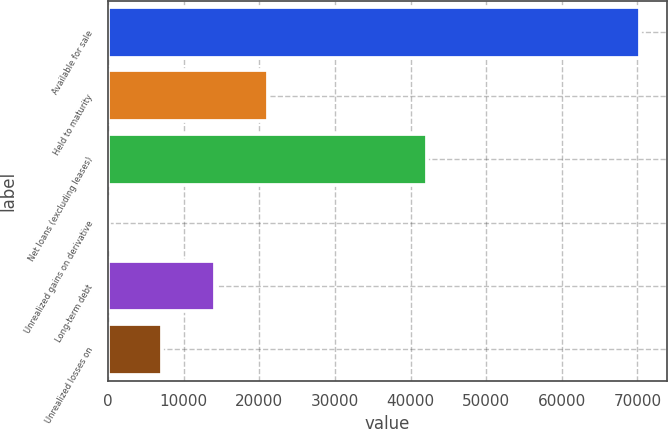Convert chart to OTSL. <chart><loc_0><loc_0><loc_500><loc_500><bar_chart><fcel>Available for sale<fcel>Held to maturity<fcel>Net loans (excluding leases)<fcel>Unrealized gains on derivative<fcel>Long-term debt<fcel>Unrealized losses on<nl><fcel>70326<fcel>21141.9<fcel>42220.8<fcel>63<fcel>14115.6<fcel>7089.3<nl></chart> 